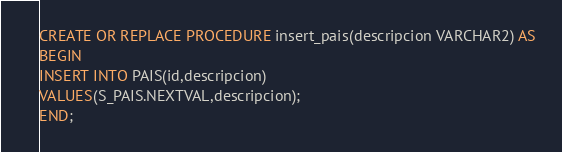<code> <loc_0><loc_0><loc_500><loc_500><_SQL_>CREATE OR REPLACE PROCEDURE insert_pais(descripcion VARCHAR2) AS
BEGIN
INSERT INTO PAIS(id,descripcion)
VALUES(S_PAIS.NEXTVAL,descripcion);
END;
</code> 